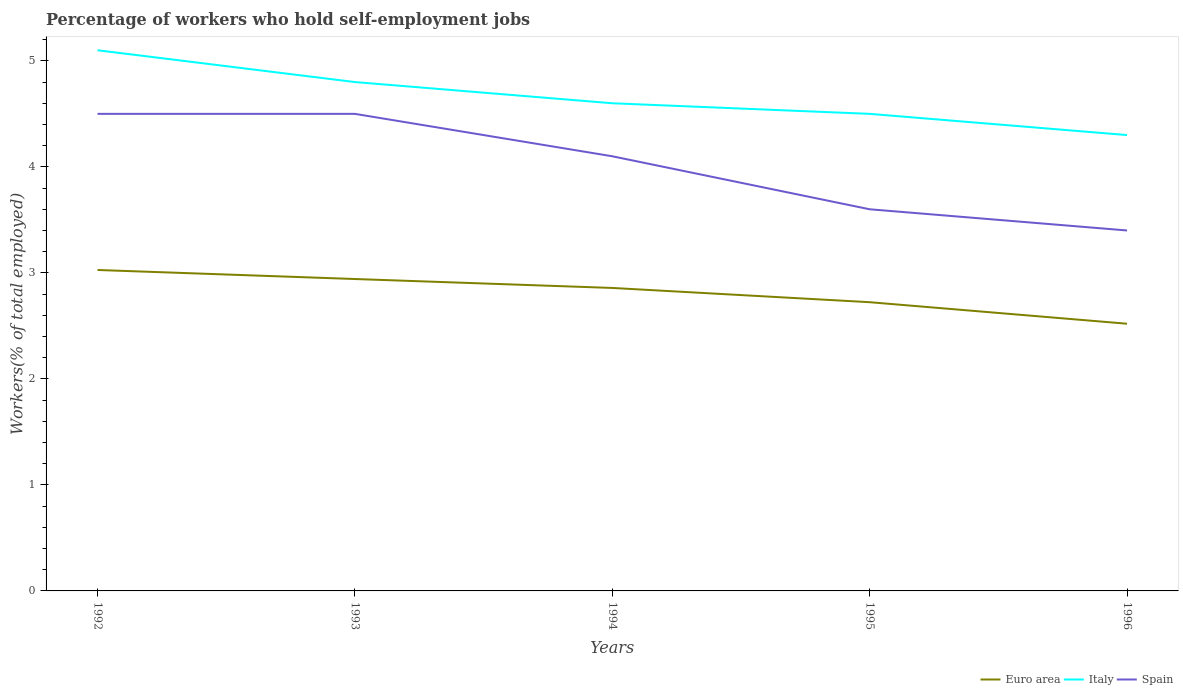How many different coloured lines are there?
Your answer should be compact. 3. Across all years, what is the maximum percentage of self-employed workers in Italy?
Your answer should be compact. 4.3. What is the total percentage of self-employed workers in Euro area in the graph?
Provide a short and direct response. 0.22. What is the difference between the highest and the second highest percentage of self-employed workers in Italy?
Give a very brief answer. 0.8. Does the graph contain grids?
Your response must be concise. No. How are the legend labels stacked?
Offer a terse response. Horizontal. What is the title of the graph?
Provide a succinct answer. Percentage of workers who hold self-employment jobs. Does "High income" appear as one of the legend labels in the graph?
Offer a very short reply. No. What is the label or title of the X-axis?
Your answer should be compact. Years. What is the label or title of the Y-axis?
Your answer should be compact. Workers(% of total employed). What is the Workers(% of total employed) in Euro area in 1992?
Your answer should be very brief. 3.03. What is the Workers(% of total employed) in Italy in 1992?
Your response must be concise. 5.1. What is the Workers(% of total employed) of Spain in 1992?
Provide a succinct answer. 4.5. What is the Workers(% of total employed) of Euro area in 1993?
Keep it short and to the point. 2.94. What is the Workers(% of total employed) in Italy in 1993?
Offer a very short reply. 4.8. What is the Workers(% of total employed) of Spain in 1993?
Provide a short and direct response. 4.5. What is the Workers(% of total employed) in Euro area in 1994?
Provide a short and direct response. 2.86. What is the Workers(% of total employed) of Italy in 1994?
Offer a terse response. 4.6. What is the Workers(% of total employed) in Spain in 1994?
Provide a short and direct response. 4.1. What is the Workers(% of total employed) in Euro area in 1995?
Make the answer very short. 2.72. What is the Workers(% of total employed) in Spain in 1995?
Provide a short and direct response. 3.6. What is the Workers(% of total employed) in Euro area in 1996?
Offer a terse response. 2.52. What is the Workers(% of total employed) in Italy in 1996?
Your response must be concise. 4.3. What is the Workers(% of total employed) in Spain in 1996?
Make the answer very short. 3.4. Across all years, what is the maximum Workers(% of total employed) of Euro area?
Offer a terse response. 3.03. Across all years, what is the maximum Workers(% of total employed) of Italy?
Ensure brevity in your answer.  5.1. Across all years, what is the maximum Workers(% of total employed) in Spain?
Give a very brief answer. 4.5. Across all years, what is the minimum Workers(% of total employed) of Euro area?
Offer a very short reply. 2.52. Across all years, what is the minimum Workers(% of total employed) of Italy?
Provide a succinct answer. 4.3. Across all years, what is the minimum Workers(% of total employed) of Spain?
Ensure brevity in your answer.  3.4. What is the total Workers(% of total employed) of Euro area in the graph?
Provide a succinct answer. 14.07. What is the total Workers(% of total employed) of Italy in the graph?
Make the answer very short. 23.3. What is the total Workers(% of total employed) in Spain in the graph?
Give a very brief answer. 20.1. What is the difference between the Workers(% of total employed) of Euro area in 1992 and that in 1993?
Your response must be concise. 0.09. What is the difference between the Workers(% of total employed) of Italy in 1992 and that in 1993?
Make the answer very short. 0.3. What is the difference between the Workers(% of total employed) of Spain in 1992 and that in 1993?
Your answer should be compact. 0. What is the difference between the Workers(% of total employed) of Euro area in 1992 and that in 1994?
Your answer should be very brief. 0.17. What is the difference between the Workers(% of total employed) in Italy in 1992 and that in 1994?
Your answer should be compact. 0.5. What is the difference between the Workers(% of total employed) of Euro area in 1992 and that in 1995?
Your answer should be compact. 0.3. What is the difference between the Workers(% of total employed) of Spain in 1992 and that in 1995?
Offer a terse response. 0.9. What is the difference between the Workers(% of total employed) in Euro area in 1992 and that in 1996?
Your answer should be compact. 0.51. What is the difference between the Workers(% of total employed) in Euro area in 1993 and that in 1994?
Provide a succinct answer. 0.08. What is the difference between the Workers(% of total employed) of Euro area in 1993 and that in 1995?
Your answer should be very brief. 0.22. What is the difference between the Workers(% of total employed) in Italy in 1993 and that in 1995?
Ensure brevity in your answer.  0.3. What is the difference between the Workers(% of total employed) of Euro area in 1993 and that in 1996?
Your answer should be very brief. 0.42. What is the difference between the Workers(% of total employed) of Euro area in 1994 and that in 1995?
Your response must be concise. 0.13. What is the difference between the Workers(% of total employed) of Euro area in 1994 and that in 1996?
Offer a very short reply. 0.34. What is the difference between the Workers(% of total employed) in Spain in 1994 and that in 1996?
Ensure brevity in your answer.  0.7. What is the difference between the Workers(% of total employed) of Euro area in 1995 and that in 1996?
Make the answer very short. 0.2. What is the difference between the Workers(% of total employed) in Italy in 1995 and that in 1996?
Your answer should be compact. 0.2. What is the difference between the Workers(% of total employed) of Euro area in 1992 and the Workers(% of total employed) of Italy in 1993?
Offer a terse response. -1.77. What is the difference between the Workers(% of total employed) in Euro area in 1992 and the Workers(% of total employed) in Spain in 1993?
Your answer should be very brief. -1.47. What is the difference between the Workers(% of total employed) in Italy in 1992 and the Workers(% of total employed) in Spain in 1993?
Give a very brief answer. 0.6. What is the difference between the Workers(% of total employed) of Euro area in 1992 and the Workers(% of total employed) of Italy in 1994?
Provide a succinct answer. -1.57. What is the difference between the Workers(% of total employed) of Euro area in 1992 and the Workers(% of total employed) of Spain in 1994?
Provide a succinct answer. -1.07. What is the difference between the Workers(% of total employed) in Italy in 1992 and the Workers(% of total employed) in Spain in 1994?
Offer a very short reply. 1. What is the difference between the Workers(% of total employed) in Euro area in 1992 and the Workers(% of total employed) in Italy in 1995?
Offer a very short reply. -1.47. What is the difference between the Workers(% of total employed) in Euro area in 1992 and the Workers(% of total employed) in Spain in 1995?
Your answer should be compact. -0.57. What is the difference between the Workers(% of total employed) in Italy in 1992 and the Workers(% of total employed) in Spain in 1995?
Offer a very short reply. 1.5. What is the difference between the Workers(% of total employed) in Euro area in 1992 and the Workers(% of total employed) in Italy in 1996?
Make the answer very short. -1.27. What is the difference between the Workers(% of total employed) in Euro area in 1992 and the Workers(% of total employed) in Spain in 1996?
Your answer should be compact. -0.37. What is the difference between the Workers(% of total employed) of Euro area in 1993 and the Workers(% of total employed) of Italy in 1994?
Provide a short and direct response. -1.66. What is the difference between the Workers(% of total employed) of Euro area in 1993 and the Workers(% of total employed) of Spain in 1994?
Provide a short and direct response. -1.16. What is the difference between the Workers(% of total employed) in Euro area in 1993 and the Workers(% of total employed) in Italy in 1995?
Your answer should be compact. -1.56. What is the difference between the Workers(% of total employed) in Euro area in 1993 and the Workers(% of total employed) in Spain in 1995?
Your response must be concise. -0.66. What is the difference between the Workers(% of total employed) of Euro area in 1993 and the Workers(% of total employed) of Italy in 1996?
Give a very brief answer. -1.36. What is the difference between the Workers(% of total employed) of Euro area in 1993 and the Workers(% of total employed) of Spain in 1996?
Ensure brevity in your answer.  -0.46. What is the difference between the Workers(% of total employed) of Italy in 1993 and the Workers(% of total employed) of Spain in 1996?
Offer a very short reply. 1.4. What is the difference between the Workers(% of total employed) in Euro area in 1994 and the Workers(% of total employed) in Italy in 1995?
Provide a short and direct response. -1.64. What is the difference between the Workers(% of total employed) in Euro area in 1994 and the Workers(% of total employed) in Spain in 1995?
Offer a very short reply. -0.74. What is the difference between the Workers(% of total employed) of Euro area in 1994 and the Workers(% of total employed) of Italy in 1996?
Keep it short and to the point. -1.44. What is the difference between the Workers(% of total employed) in Euro area in 1994 and the Workers(% of total employed) in Spain in 1996?
Keep it short and to the point. -0.54. What is the difference between the Workers(% of total employed) of Euro area in 1995 and the Workers(% of total employed) of Italy in 1996?
Keep it short and to the point. -1.58. What is the difference between the Workers(% of total employed) of Euro area in 1995 and the Workers(% of total employed) of Spain in 1996?
Provide a short and direct response. -0.68. What is the average Workers(% of total employed) of Euro area per year?
Your answer should be compact. 2.81. What is the average Workers(% of total employed) of Italy per year?
Make the answer very short. 4.66. What is the average Workers(% of total employed) of Spain per year?
Provide a short and direct response. 4.02. In the year 1992, what is the difference between the Workers(% of total employed) in Euro area and Workers(% of total employed) in Italy?
Make the answer very short. -2.07. In the year 1992, what is the difference between the Workers(% of total employed) of Euro area and Workers(% of total employed) of Spain?
Your answer should be very brief. -1.47. In the year 1992, what is the difference between the Workers(% of total employed) of Italy and Workers(% of total employed) of Spain?
Give a very brief answer. 0.6. In the year 1993, what is the difference between the Workers(% of total employed) of Euro area and Workers(% of total employed) of Italy?
Provide a succinct answer. -1.86. In the year 1993, what is the difference between the Workers(% of total employed) in Euro area and Workers(% of total employed) in Spain?
Your response must be concise. -1.56. In the year 1993, what is the difference between the Workers(% of total employed) of Italy and Workers(% of total employed) of Spain?
Offer a very short reply. 0.3. In the year 1994, what is the difference between the Workers(% of total employed) in Euro area and Workers(% of total employed) in Italy?
Your answer should be compact. -1.74. In the year 1994, what is the difference between the Workers(% of total employed) of Euro area and Workers(% of total employed) of Spain?
Ensure brevity in your answer.  -1.24. In the year 1994, what is the difference between the Workers(% of total employed) of Italy and Workers(% of total employed) of Spain?
Your response must be concise. 0.5. In the year 1995, what is the difference between the Workers(% of total employed) of Euro area and Workers(% of total employed) of Italy?
Give a very brief answer. -1.78. In the year 1995, what is the difference between the Workers(% of total employed) in Euro area and Workers(% of total employed) in Spain?
Offer a terse response. -0.88. In the year 1995, what is the difference between the Workers(% of total employed) of Italy and Workers(% of total employed) of Spain?
Provide a succinct answer. 0.9. In the year 1996, what is the difference between the Workers(% of total employed) in Euro area and Workers(% of total employed) in Italy?
Your answer should be compact. -1.78. In the year 1996, what is the difference between the Workers(% of total employed) of Euro area and Workers(% of total employed) of Spain?
Your response must be concise. -0.88. What is the ratio of the Workers(% of total employed) in Italy in 1992 to that in 1993?
Provide a succinct answer. 1.06. What is the ratio of the Workers(% of total employed) in Spain in 1992 to that in 1993?
Offer a very short reply. 1. What is the ratio of the Workers(% of total employed) in Euro area in 1992 to that in 1994?
Your response must be concise. 1.06. What is the ratio of the Workers(% of total employed) in Italy in 1992 to that in 1994?
Keep it short and to the point. 1.11. What is the ratio of the Workers(% of total employed) in Spain in 1992 to that in 1994?
Your answer should be very brief. 1.1. What is the ratio of the Workers(% of total employed) in Euro area in 1992 to that in 1995?
Offer a very short reply. 1.11. What is the ratio of the Workers(% of total employed) of Italy in 1992 to that in 1995?
Your response must be concise. 1.13. What is the ratio of the Workers(% of total employed) of Euro area in 1992 to that in 1996?
Your response must be concise. 1.2. What is the ratio of the Workers(% of total employed) of Italy in 1992 to that in 1996?
Ensure brevity in your answer.  1.19. What is the ratio of the Workers(% of total employed) of Spain in 1992 to that in 1996?
Provide a succinct answer. 1.32. What is the ratio of the Workers(% of total employed) of Euro area in 1993 to that in 1994?
Provide a succinct answer. 1.03. What is the ratio of the Workers(% of total employed) in Italy in 1993 to that in 1994?
Give a very brief answer. 1.04. What is the ratio of the Workers(% of total employed) of Spain in 1993 to that in 1994?
Ensure brevity in your answer.  1.1. What is the ratio of the Workers(% of total employed) of Euro area in 1993 to that in 1995?
Provide a succinct answer. 1.08. What is the ratio of the Workers(% of total employed) in Italy in 1993 to that in 1995?
Ensure brevity in your answer.  1.07. What is the ratio of the Workers(% of total employed) of Spain in 1993 to that in 1995?
Your response must be concise. 1.25. What is the ratio of the Workers(% of total employed) in Euro area in 1993 to that in 1996?
Provide a short and direct response. 1.17. What is the ratio of the Workers(% of total employed) of Italy in 1993 to that in 1996?
Your answer should be very brief. 1.12. What is the ratio of the Workers(% of total employed) in Spain in 1993 to that in 1996?
Give a very brief answer. 1.32. What is the ratio of the Workers(% of total employed) in Euro area in 1994 to that in 1995?
Offer a terse response. 1.05. What is the ratio of the Workers(% of total employed) in Italy in 1994 to that in 1995?
Provide a succinct answer. 1.02. What is the ratio of the Workers(% of total employed) in Spain in 1994 to that in 1995?
Give a very brief answer. 1.14. What is the ratio of the Workers(% of total employed) of Euro area in 1994 to that in 1996?
Your response must be concise. 1.13. What is the ratio of the Workers(% of total employed) of Italy in 1994 to that in 1996?
Your answer should be compact. 1.07. What is the ratio of the Workers(% of total employed) of Spain in 1994 to that in 1996?
Your answer should be compact. 1.21. What is the ratio of the Workers(% of total employed) of Euro area in 1995 to that in 1996?
Your answer should be very brief. 1.08. What is the ratio of the Workers(% of total employed) of Italy in 1995 to that in 1996?
Make the answer very short. 1.05. What is the ratio of the Workers(% of total employed) of Spain in 1995 to that in 1996?
Your answer should be compact. 1.06. What is the difference between the highest and the second highest Workers(% of total employed) in Euro area?
Make the answer very short. 0.09. What is the difference between the highest and the second highest Workers(% of total employed) in Italy?
Make the answer very short. 0.3. What is the difference between the highest and the second highest Workers(% of total employed) of Spain?
Make the answer very short. 0. What is the difference between the highest and the lowest Workers(% of total employed) in Euro area?
Your answer should be very brief. 0.51. What is the difference between the highest and the lowest Workers(% of total employed) in Italy?
Give a very brief answer. 0.8. 